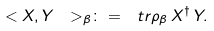<formula> <loc_0><loc_0><loc_500><loc_500>\ < X , Y \ > _ { \beta } \colon = \ t r \rho _ { \beta } \, X ^ { \dagger } \, Y .</formula> 